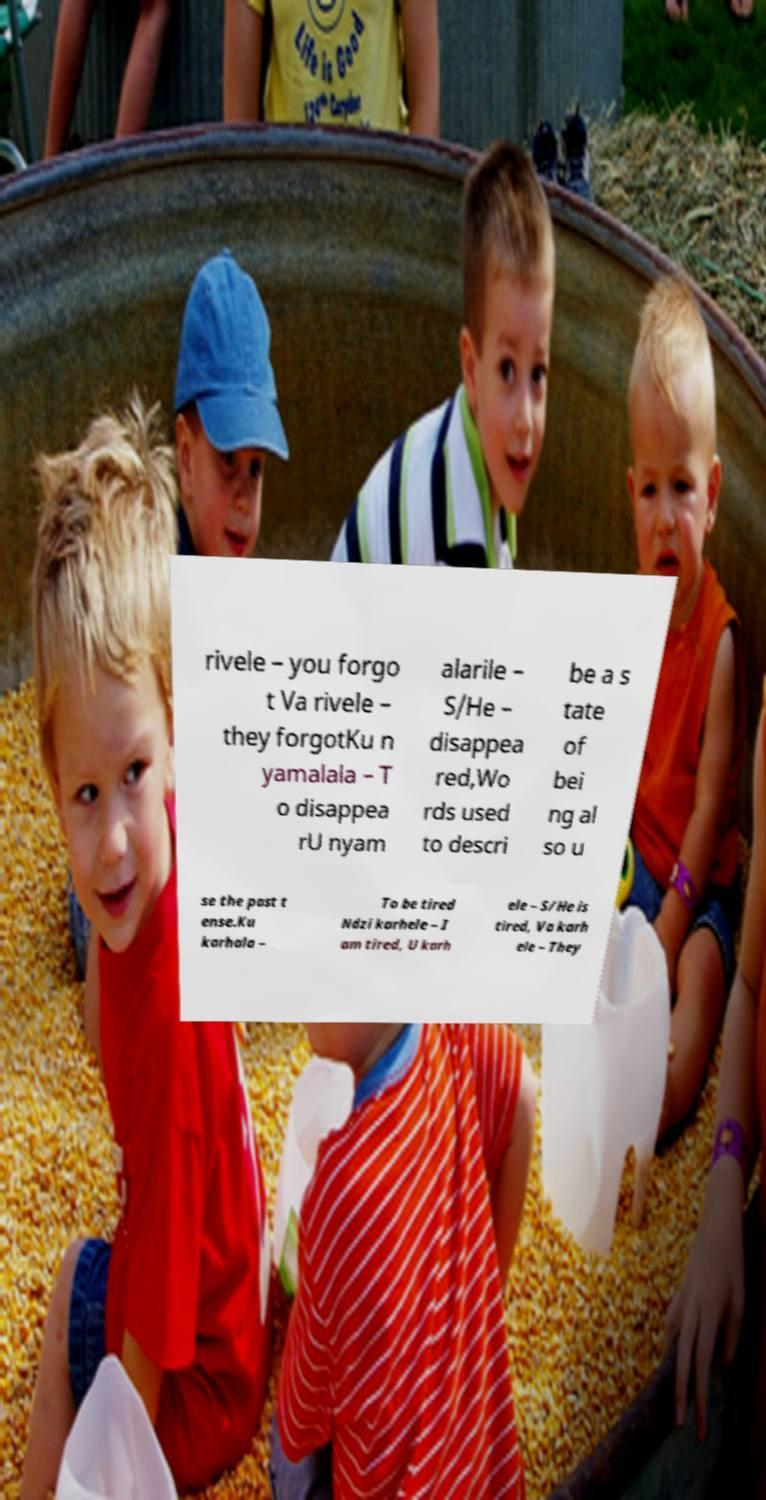What messages or text are displayed in this image? I need them in a readable, typed format. rivele – you forgo t Va rivele – they forgotKu n yamalala – T o disappea rU nyam alarile – S/He – disappea red,Wo rds used to descri be a s tate of bei ng al so u se the past t ense.Ku karhala – To be tired Ndzi karhele – I am tired, U karh ele – S/He is tired, Va karh ele – They 